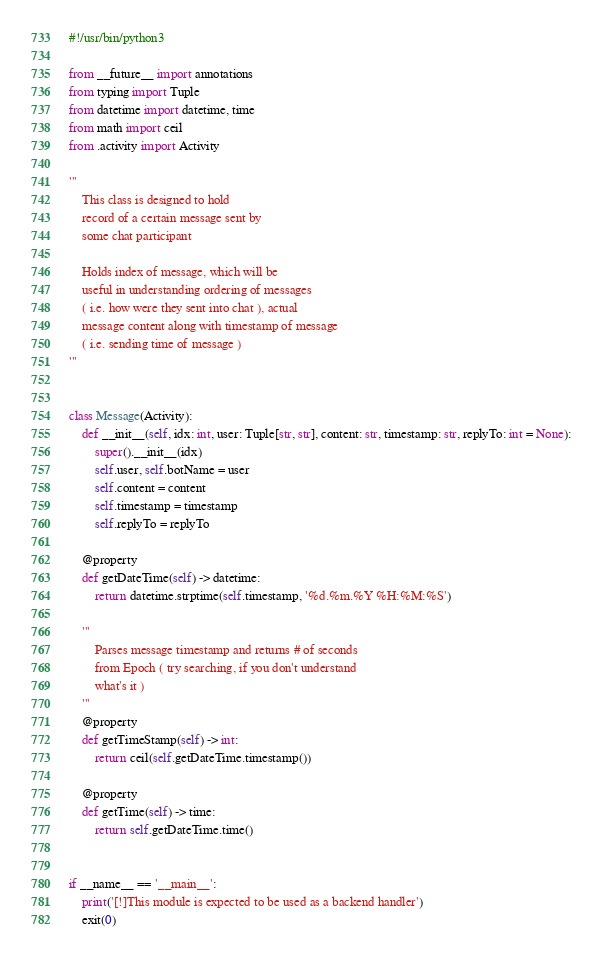<code> <loc_0><loc_0><loc_500><loc_500><_Python_>#!/usr/bin/python3

from __future__ import annotations
from typing import Tuple
from datetime import datetime, time
from math import ceil
from .activity import Activity

'''
    This class is designed to hold
    record of a certain message sent by
    some chat participant

    Holds index of message, which will be
    useful in understanding ordering of messages
    ( i.e. how were they sent into chat ), actual
    message content along with timestamp of message
    ( i.e. sending time of message )
'''


class Message(Activity):
    def __init__(self, idx: int, user: Tuple[str, str], content: str, timestamp: str, replyTo: int = None):
        super().__init__(idx)
        self.user, self.botName = user
        self.content = content
        self.timestamp = timestamp
        self.replyTo = replyTo

    @property
    def getDateTime(self) -> datetime:
        return datetime.strptime(self.timestamp, '%d.%m.%Y %H:%M:%S')

    '''
        Parses message timestamp and returns # of seconds
        from Epoch ( try searching, if you don't understand
        what's it )
    '''
    @property
    def getTimeStamp(self) -> int:
        return ceil(self.getDateTime.timestamp())

    @property
    def getTime(self) -> time:
        return self.getDateTime.time()


if __name__ == '__main__':
    print('[!]This module is expected to be used as a backend handler')
    exit(0)
</code> 